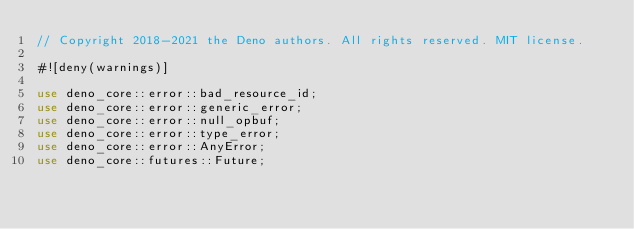Convert code to text. <code><loc_0><loc_0><loc_500><loc_500><_Rust_>// Copyright 2018-2021 the Deno authors. All rights reserved. MIT license.

#![deny(warnings)]

use deno_core::error::bad_resource_id;
use deno_core::error::generic_error;
use deno_core::error::null_opbuf;
use deno_core::error::type_error;
use deno_core::error::AnyError;
use deno_core::futures::Future;</code> 